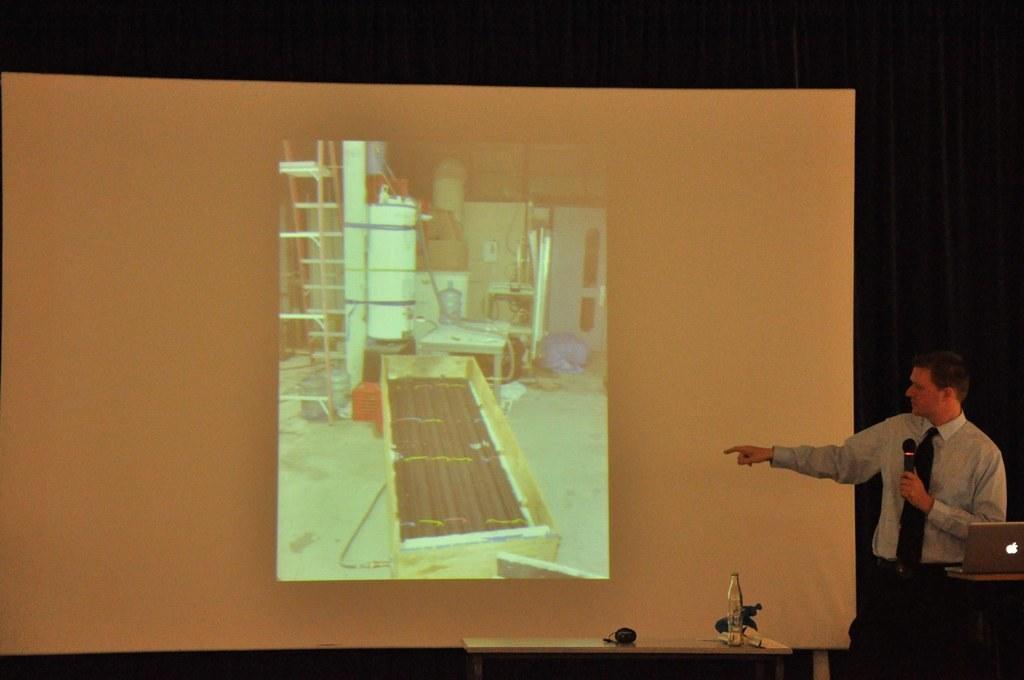Describe this image in one or two sentences. On the right side of the image we can see a man standing and holding a mic in his hand, before him there is a table and we can see a laptop placed on the table. In the center there is a screen. At the bottom there is a stand and we can see things placed on the stand. 